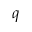<formula> <loc_0><loc_0><loc_500><loc_500>q</formula> 